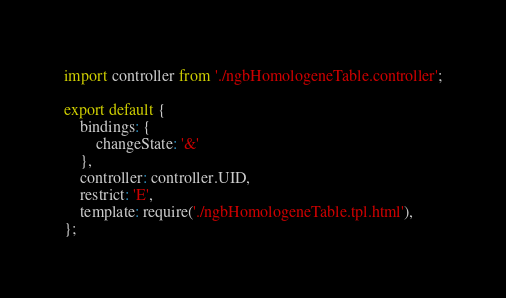Convert code to text. <code><loc_0><loc_0><loc_500><loc_500><_JavaScript_>import controller from './ngbHomologeneTable.controller';

export default {
    bindings: {
        changeState: '&'
    },
    controller: controller.UID,
    restrict: 'E',
    template: require('./ngbHomologeneTable.tpl.html'),
};
</code> 